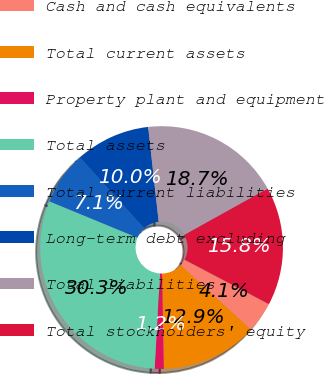<chart> <loc_0><loc_0><loc_500><loc_500><pie_chart><fcel>Cash and cash equivalents<fcel>Total current assets<fcel>Property plant and equipment<fcel>Total assets<fcel>Total current liabilities<fcel>Long-term debt excluding<fcel>Total liabilities<fcel>Total stockholders' equity<nl><fcel>4.12%<fcel>12.87%<fcel>1.21%<fcel>30.31%<fcel>7.05%<fcel>9.96%<fcel>18.69%<fcel>15.78%<nl></chart> 